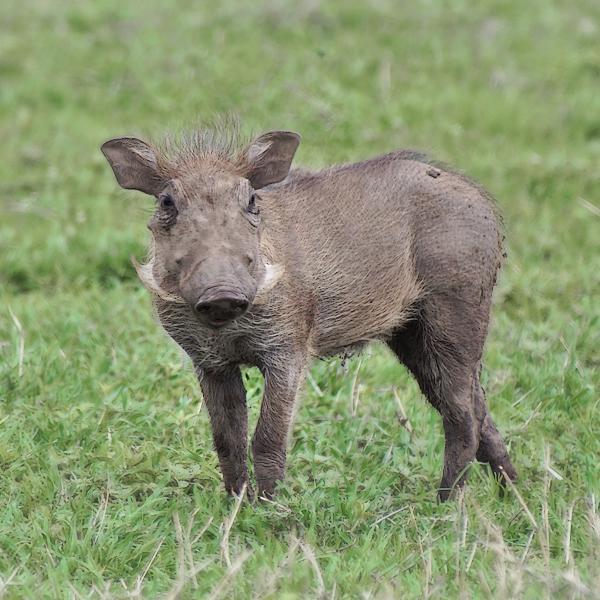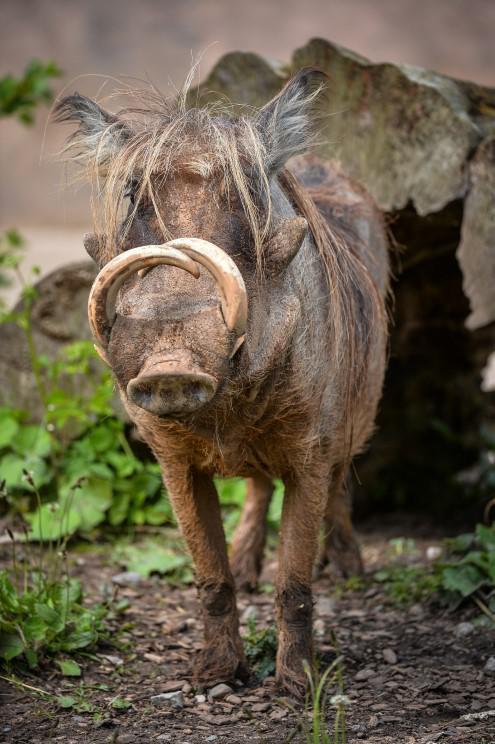The first image is the image on the left, the second image is the image on the right. Evaluate the accuracy of this statement regarding the images: "At least one image contains more than one warthog.". Is it true? Answer yes or no. No. 